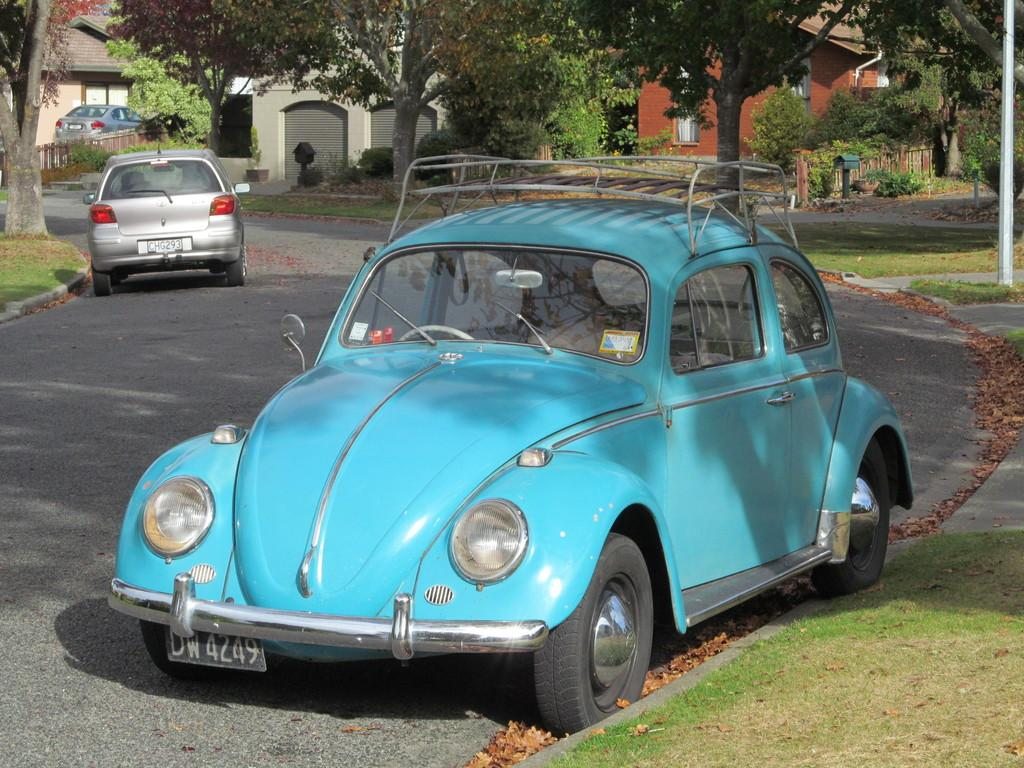What can be seen on the road in the image? There are vehicles on the road in the image. What is visible in the background of the image? There are houses, trees, grass, poles, and other objects on the ground in the background of the image. Can you describe the setting of the image? The image shows a road with vehicles, surrounded by houses, trees, grass, and poles in the background. What type of clam is being discussed in the meeting in the image? There is no meeting or clam present in the image; it shows vehicles on a road with a background of houses, trees, grass, and poles. 